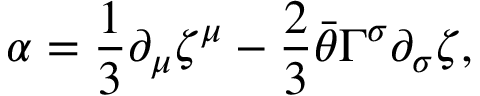<formula> <loc_0><loc_0><loc_500><loc_500>\alpha = { \frac { 1 } { 3 } } \partial _ { \mu } \zeta ^ { \mu } - { \frac { 2 } { 3 } } \bar { \theta } \Gamma ^ { \sigma } \partial _ { \sigma } \zeta ,</formula> 